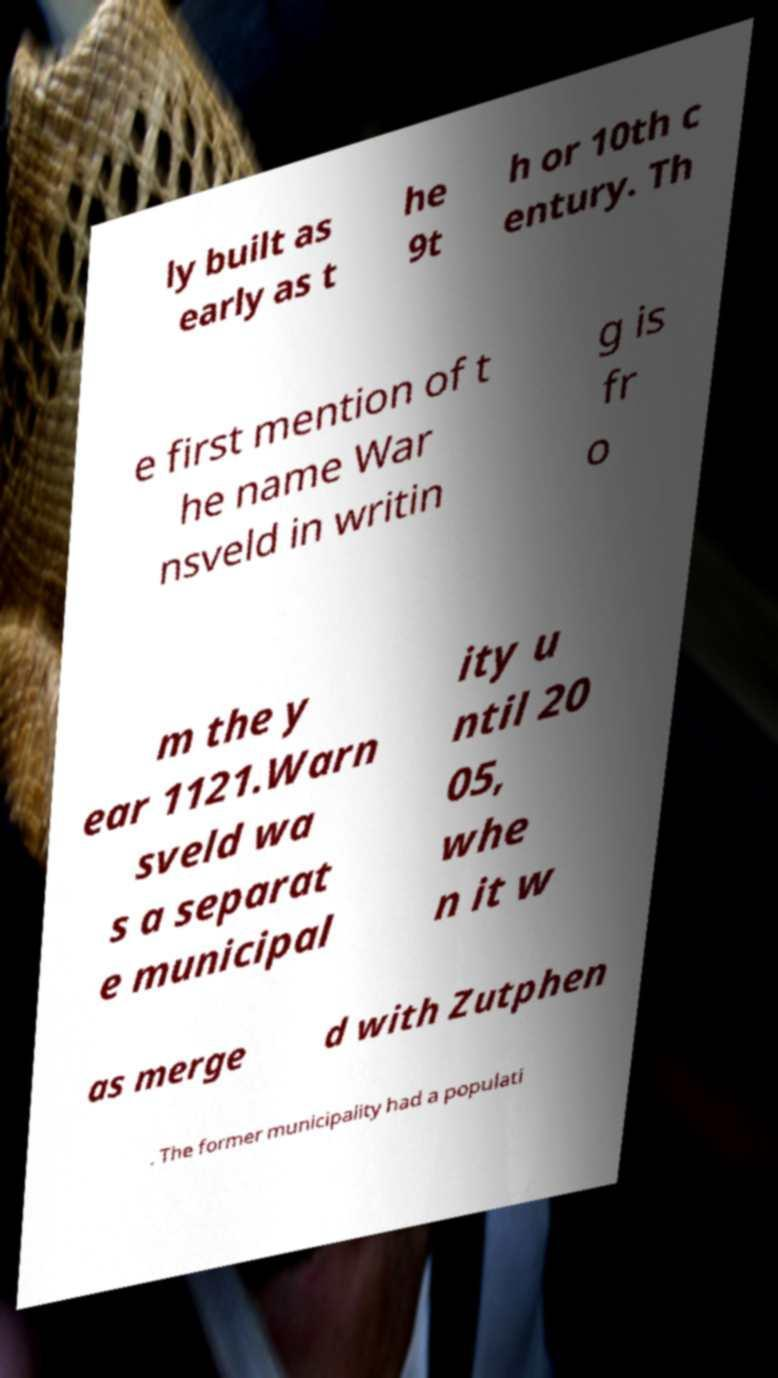For documentation purposes, I need the text within this image transcribed. Could you provide that? ly built as early as t he 9t h or 10th c entury. Th e first mention of t he name War nsveld in writin g is fr o m the y ear 1121.Warn sveld wa s a separat e municipal ity u ntil 20 05, whe n it w as merge d with Zutphen . The former municipality had a populati 